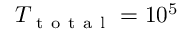<formula> <loc_0><loc_0><loc_500><loc_500>{ T _ { t o t a l } } = 1 0 ^ { 5 }</formula> 